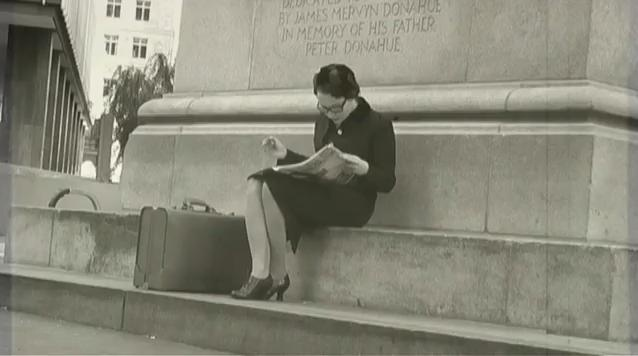Describe the objects in this image and their specific colors. I can see people in black, gray, and darkgray tones, suitcase in black, gray, and darkgray tones, and book in black and gray tones in this image. 